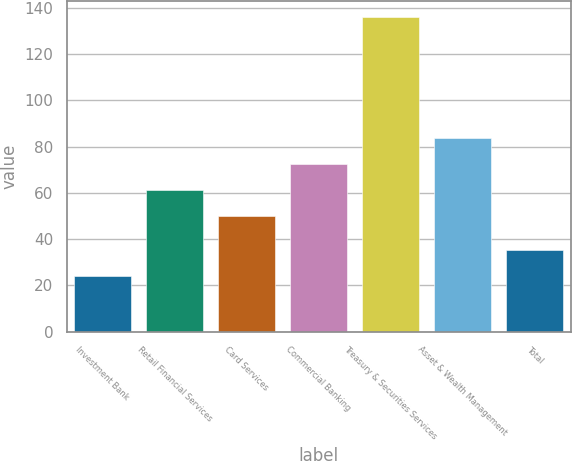Convert chart. <chart><loc_0><loc_0><loc_500><loc_500><bar_chart><fcel>Investment Bank<fcel>Retail Financial Services<fcel>Card Services<fcel>Commercial Banking<fcel>Treasury & Securities Services<fcel>Asset & Wealth Management<fcel>Total<nl><fcel>24<fcel>61.2<fcel>50<fcel>72.4<fcel>136<fcel>83.6<fcel>35.2<nl></chart> 